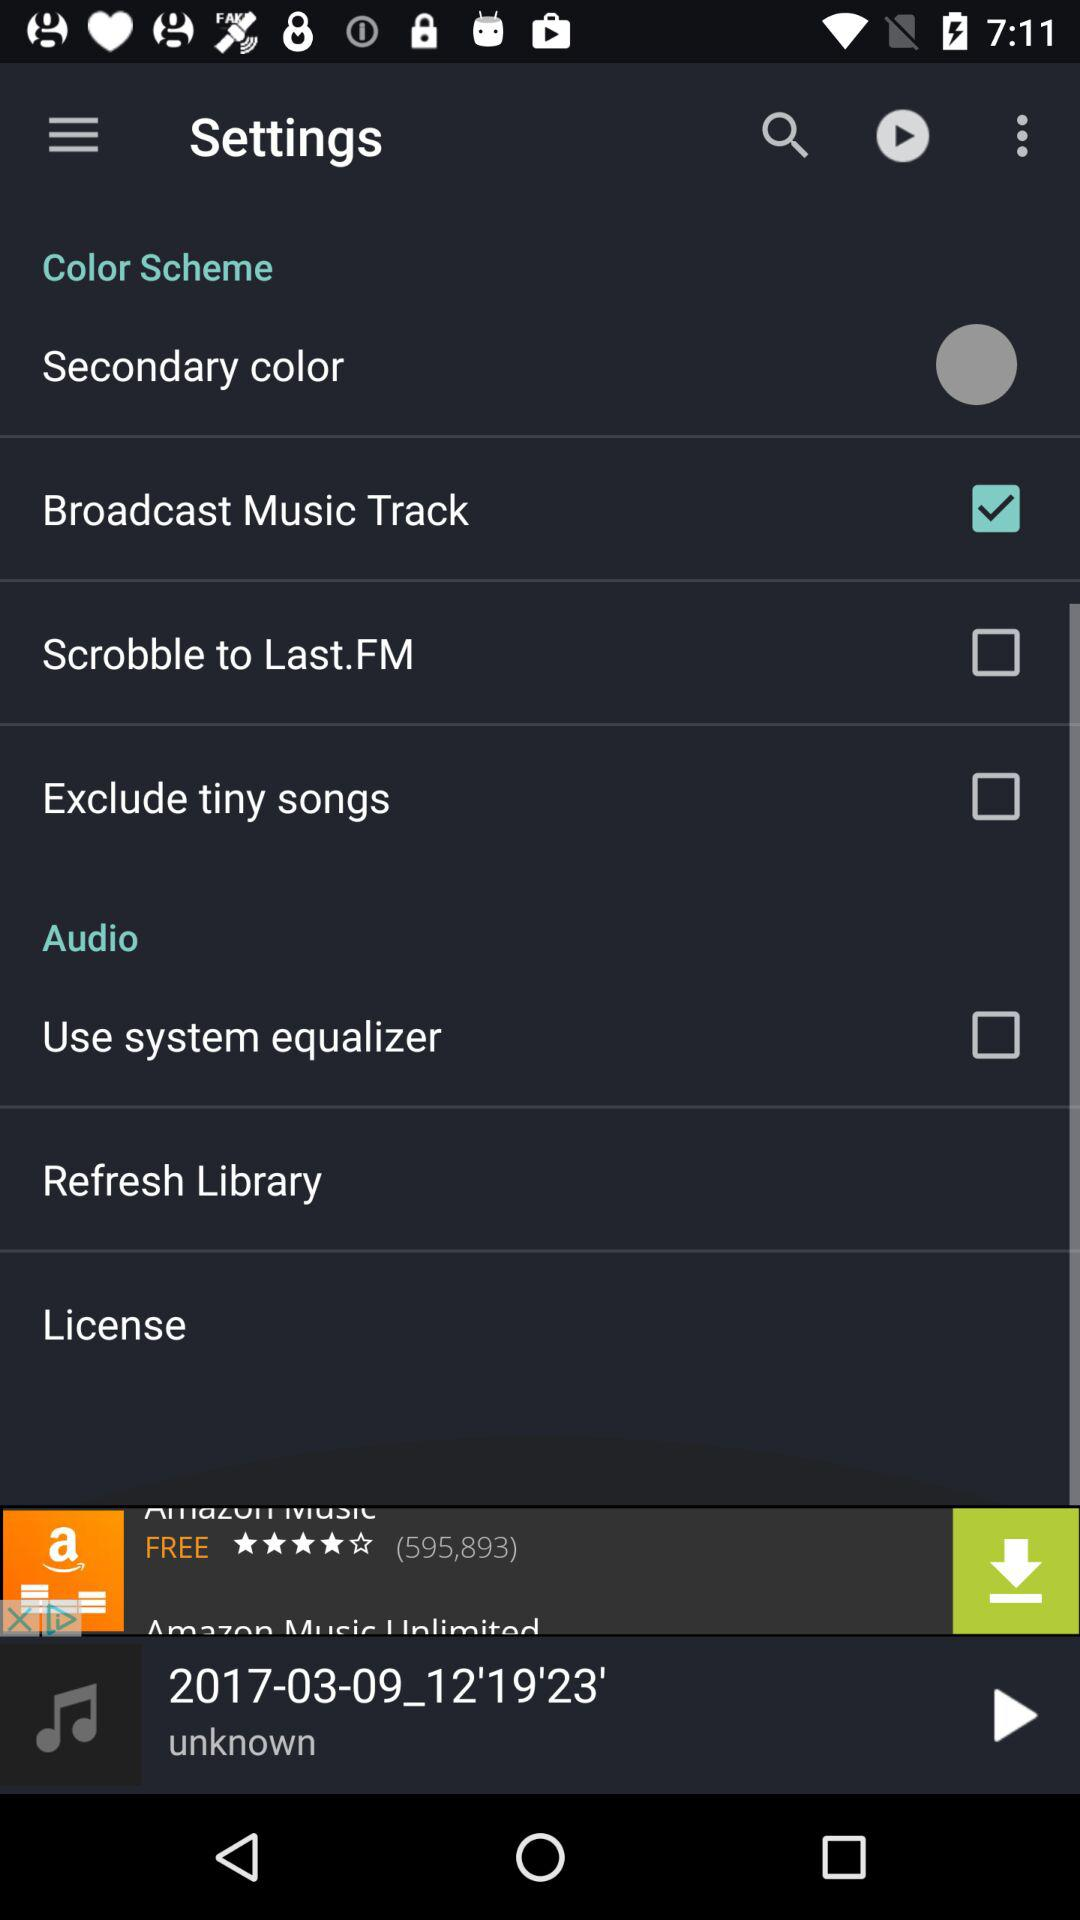What is the state of the "Scrobble to Last.FM" setting? The status is "off". 